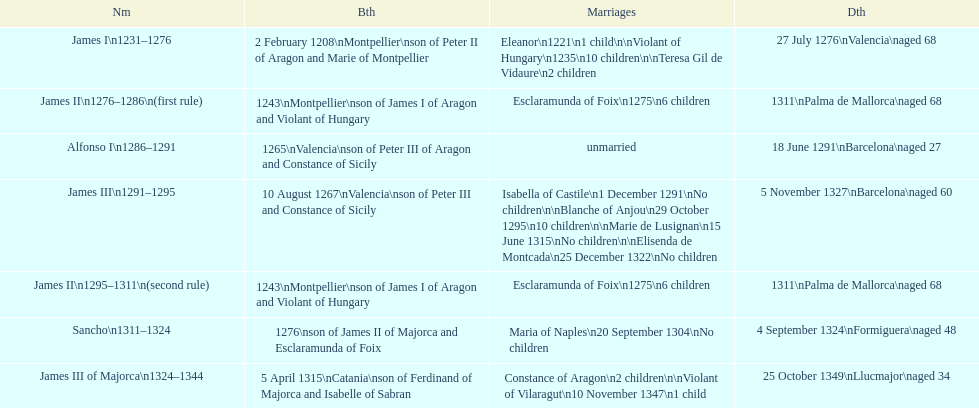Which monarch had the most marriages? James III 1291-1295. 